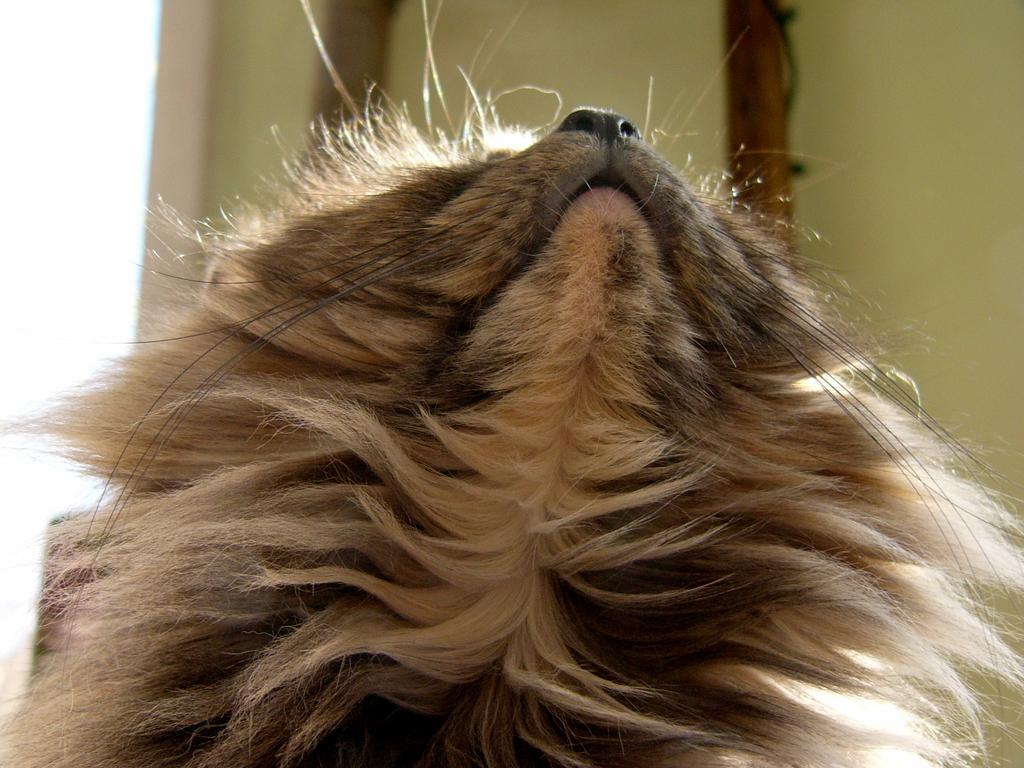In one or two sentences, can you explain what this image depicts? As we can see in the image there is a wall and an animal. 